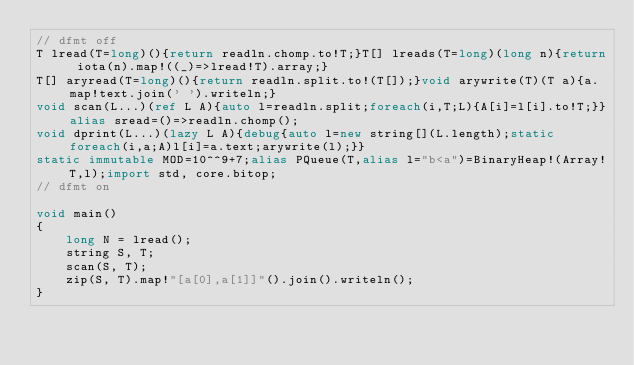<code> <loc_0><loc_0><loc_500><loc_500><_D_>// dfmt off
T lread(T=long)(){return readln.chomp.to!T;}T[] lreads(T=long)(long n){return iota(n).map!((_)=>lread!T).array;}
T[] aryread(T=long)(){return readln.split.to!(T[]);}void arywrite(T)(T a){a.map!text.join(' ').writeln;}
void scan(L...)(ref L A){auto l=readln.split;foreach(i,T;L){A[i]=l[i].to!T;}}alias sread=()=>readln.chomp();
void dprint(L...)(lazy L A){debug{auto l=new string[](L.length);static foreach(i,a;A)l[i]=a.text;arywrite(l);}}
static immutable MOD=10^^9+7;alias PQueue(T,alias l="b<a")=BinaryHeap!(Array!T,l);import std, core.bitop;
// dfmt on

void main()
{
    long N = lread();
    string S, T;
    scan(S, T);
    zip(S, T).map!"[a[0],a[1]]"().join().writeln();
}
</code> 